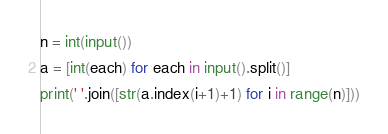Convert code to text. <code><loc_0><loc_0><loc_500><loc_500><_Python_>n = int(input())
a = [int(each) for each in input().split()]
print(' '.join([str(a.index(i+1)+1) for i in range(n)]))</code> 